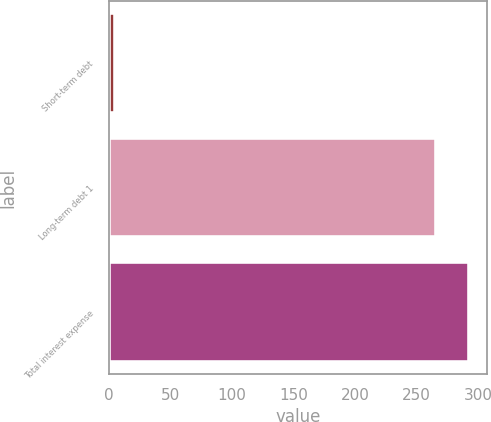Convert chart to OTSL. <chart><loc_0><loc_0><loc_500><loc_500><bar_chart><fcel>Short-term debt<fcel>Long-term debt 1<fcel>Total interest expense<nl><fcel>5<fcel>266<fcel>292.6<nl></chart> 